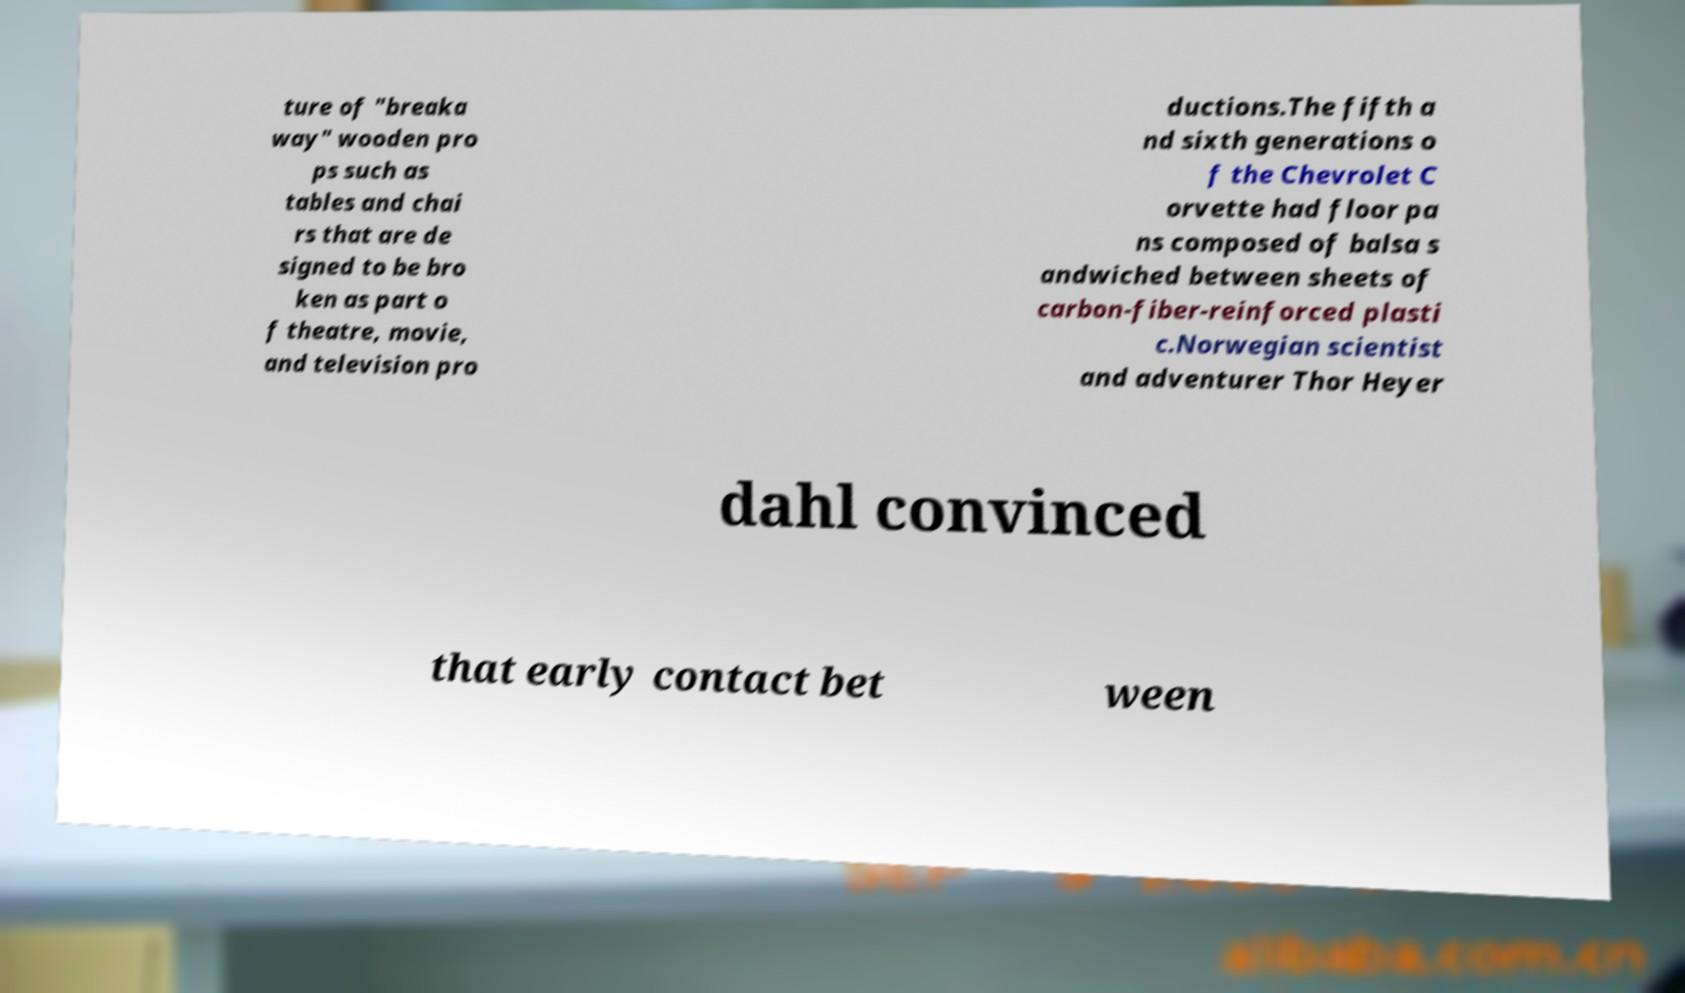What messages or text are displayed in this image? I need them in a readable, typed format. ture of "breaka way" wooden pro ps such as tables and chai rs that are de signed to be bro ken as part o f theatre, movie, and television pro ductions.The fifth a nd sixth generations o f the Chevrolet C orvette had floor pa ns composed of balsa s andwiched between sheets of carbon-fiber-reinforced plasti c.Norwegian scientist and adventurer Thor Heyer dahl convinced that early contact bet ween 